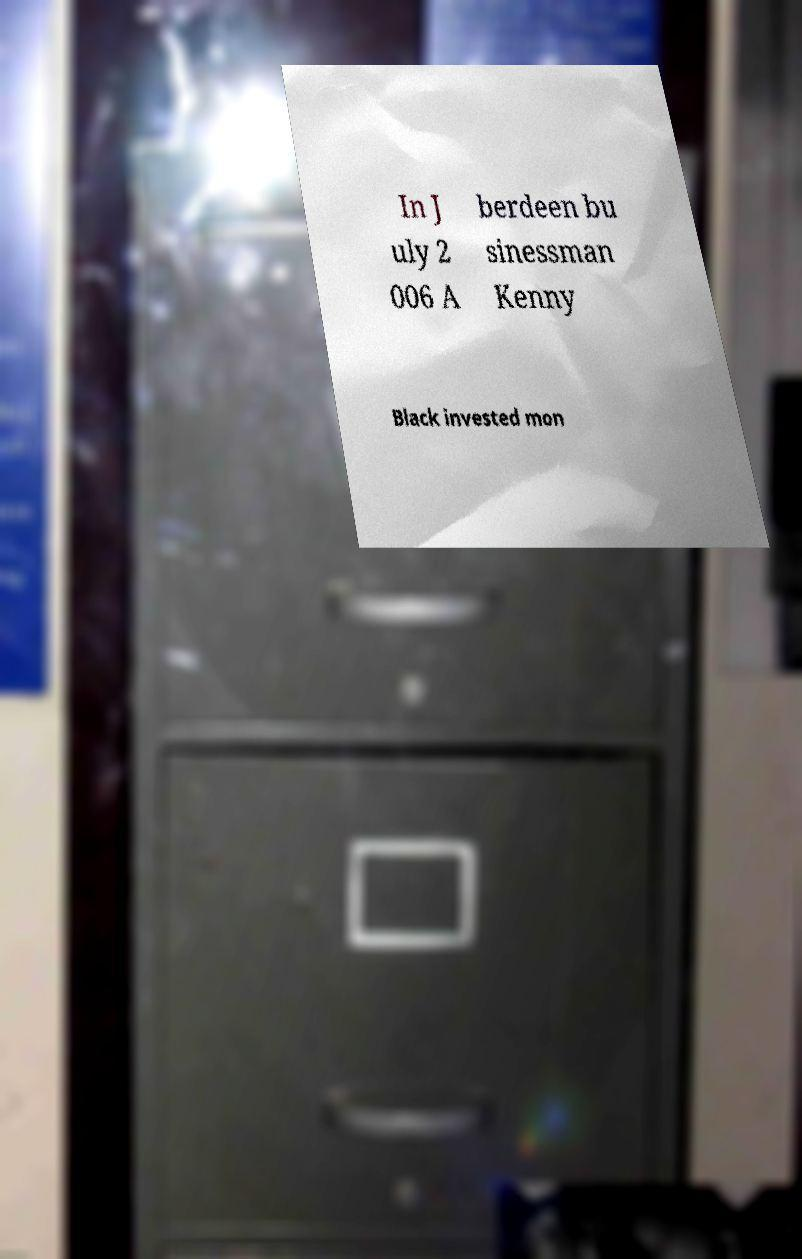Please identify and transcribe the text found in this image. In J uly 2 006 A berdeen bu sinessman Kenny Black invested mon 